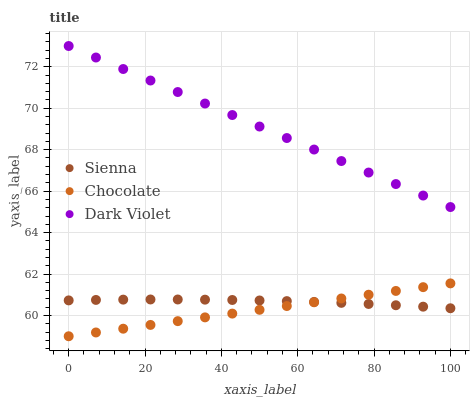Does Chocolate have the minimum area under the curve?
Answer yes or no. Yes. Does Dark Violet have the maximum area under the curve?
Answer yes or no. Yes. Does Dark Violet have the minimum area under the curve?
Answer yes or no. No. Does Chocolate have the maximum area under the curve?
Answer yes or no. No. Is Dark Violet the smoothest?
Answer yes or no. Yes. Is Sienna the roughest?
Answer yes or no. Yes. Is Chocolate the smoothest?
Answer yes or no. No. Is Chocolate the roughest?
Answer yes or no. No. Does Chocolate have the lowest value?
Answer yes or no. Yes. Does Dark Violet have the lowest value?
Answer yes or no. No. Does Dark Violet have the highest value?
Answer yes or no. Yes. Does Chocolate have the highest value?
Answer yes or no. No. Is Chocolate less than Dark Violet?
Answer yes or no. Yes. Is Dark Violet greater than Chocolate?
Answer yes or no. Yes. Does Sienna intersect Chocolate?
Answer yes or no. Yes. Is Sienna less than Chocolate?
Answer yes or no. No. Is Sienna greater than Chocolate?
Answer yes or no. No. Does Chocolate intersect Dark Violet?
Answer yes or no. No. 